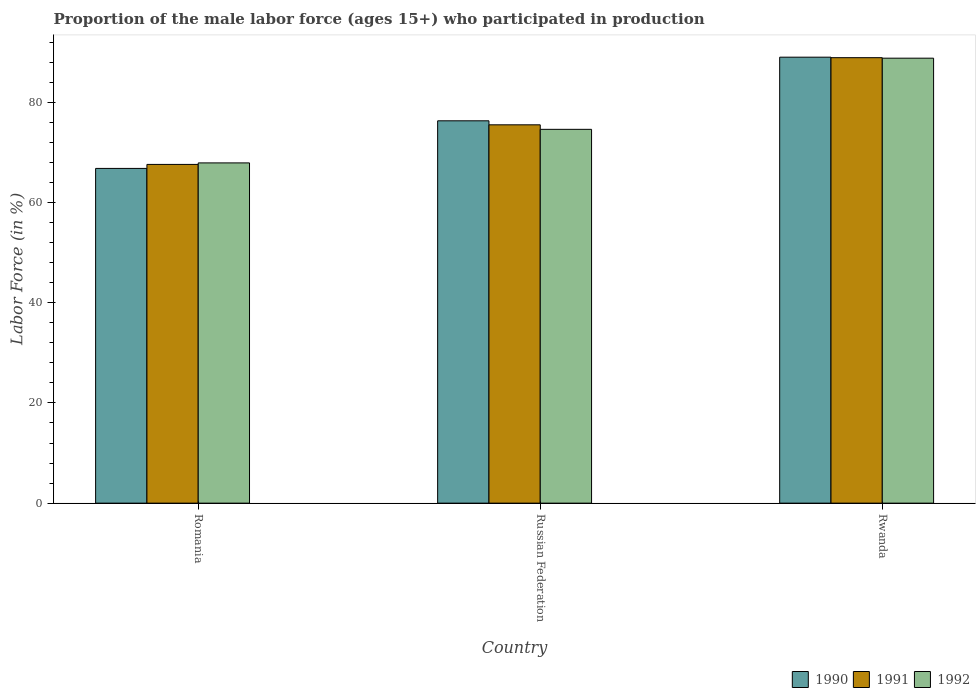Are the number of bars per tick equal to the number of legend labels?
Your response must be concise. Yes. Are the number of bars on each tick of the X-axis equal?
Make the answer very short. Yes. How many bars are there on the 3rd tick from the right?
Your answer should be very brief. 3. What is the label of the 3rd group of bars from the left?
Make the answer very short. Rwanda. What is the proportion of the male labor force who participated in production in 1990 in Romania?
Offer a very short reply. 66.8. Across all countries, what is the maximum proportion of the male labor force who participated in production in 1992?
Offer a very short reply. 88.8. Across all countries, what is the minimum proportion of the male labor force who participated in production in 1991?
Your answer should be compact. 67.6. In which country was the proportion of the male labor force who participated in production in 1990 maximum?
Your response must be concise. Rwanda. In which country was the proportion of the male labor force who participated in production in 1992 minimum?
Your response must be concise. Romania. What is the total proportion of the male labor force who participated in production in 1991 in the graph?
Give a very brief answer. 232. What is the difference between the proportion of the male labor force who participated in production in 1991 in Russian Federation and that in Rwanda?
Your answer should be compact. -13.4. What is the difference between the proportion of the male labor force who participated in production in 1992 in Romania and the proportion of the male labor force who participated in production in 1990 in Rwanda?
Your answer should be very brief. -21.1. What is the average proportion of the male labor force who participated in production in 1990 per country?
Your answer should be compact. 77.37. What is the difference between the proportion of the male labor force who participated in production of/in 1992 and proportion of the male labor force who participated in production of/in 1991 in Rwanda?
Provide a short and direct response. -0.1. What is the ratio of the proportion of the male labor force who participated in production in 1990 in Romania to that in Rwanda?
Give a very brief answer. 0.75. What is the difference between the highest and the second highest proportion of the male labor force who participated in production in 1992?
Keep it short and to the point. 14.2. What is the difference between the highest and the lowest proportion of the male labor force who participated in production in 1992?
Provide a succinct answer. 20.9. Is the sum of the proportion of the male labor force who participated in production in 1990 in Romania and Russian Federation greater than the maximum proportion of the male labor force who participated in production in 1992 across all countries?
Your response must be concise. Yes. What does the 1st bar from the left in Russian Federation represents?
Your response must be concise. 1990. What does the 3rd bar from the right in Romania represents?
Provide a short and direct response. 1990. What is the difference between two consecutive major ticks on the Y-axis?
Ensure brevity in your answer.  20. Are the values on the major ticks of Y-axis written in scientific E-notation?
Give a very brief answer. No. Where does the legend appear in the graph?
Your answer should be very brief. Bottom right. How many legend labels are there?
Ensure brevity in your answer.  3. How are the legend labels stacked?
Your response must be concise. Horizontal. What is the title of the graph?
Keep it short and to the point. Proportion of the male labor force (ages 15+) who participated in production. What is the label or title of the X-axis?
Make the answer very short. Country. What is the Labor Force (in %) of 1990 in Romania?
Give a very brief answer. 66.8. What is the Labor Force (in %) of 1991 in Romania?
Offer a very short reply. 67.6. What is the Labor Force (in %) in 1992 in Romania?
Ensure brevity in your answer.  67.9. What is the Labor Force (in %) in 1990 in Russian Federation?
Provide a succinct answer. 76.3. What is the Labor Force (in %) of 1991 in Russian Federation?
Your answer should be very brief. 75.5. What is the Labor Force (in %) of 1992 in Russian Federation?
Provide a succinct answer. 74.6. What is the Labor Force (in %) in 1990 in Rwanda?
Your answer should be compact. 89. What is the Labor Force (in %) in 1991 in Rwanda?
Give a very brief answer. 88.9. What is the Labor Force (in %) of 1992 in Rwanda?
Provide a succinct answer. 88.8. Across all countries, what is the maximum Labor Force (in %) of 1990?
Provide a succinct answer. 89. Across all countries, what is the maximum Labor Force (in %) of 1991?
Your answer should be compact. 88.9. Across all countries, what is the maximum Labor Force (in %) in 1992?
Your answer should be compact. 88.8. Across all countries, what is the minimum Labor Force (in %) in 1990?
Give a very brief answer. 66.8. Across all countries, what is the minimum Labor Force (in %) in 1991?
Your answer should be very brief. 67.6. Across all countries, what is the minimum Labor Force (in %) in 1992?
Make the answer very short. 67.9. What is the total Labor Force (in %) in 1990 in the graph?
Give a very brief answer. 232.1. What is the total Labor Force (in %) of 1991 in the graph?
Provide a succinct answer. 232. What is the total Labor Force (in %) in 1992 in the graph?
Provide a short and direct response. 231.3. What is the difference between the Labor Force (in %) of 1990 in Romania and that in Russian Federation?
Offer a terse response. -9.5. What is the difference between the Labor Force (in %) of 1992 in Romania and that in Russian Federation?
Offer a very short reply. -6.7. What is the difference between the Labor Force (in %) in 1990 in Romania and that in Rwanda?
Your response must be concise. -22.2. What is the difference between the Labor Force (in %) in 1991 in Romania and that in Rwanda?
Offer a terse response. -21.3. What is the difference between the Labor Force (in %) of 1992 in Romania and that in Rwanda?
Give a very brief answer. -20.9. What is the difference between the Labor Force (in %) of 1991 in Russian Federation and that in Rwanda?
Your answer should be very brief. -13.4. What is the difference between the Labor Force (in %) in 1990 in Romania and the Labor Force (in %) in 1991 in Russian Federation?
Your answer should be compact. -8.7. What is the difference between the Labor Force (in %) of 1990 in Romania and the Labor Force (in %) of 1992 in Russian Federation?
Offer a very short reply. -7.8. What is the difference between the Labor Force (in %) in 1991 in Romania and the Labor Force (in %) in 1992 in Russian Federation?
Give a very brief answer. -7. What is the difference between the Labor Force (in %) in 1990 in Romania and the Labor Force (in %) in 1991 in Rwanda?
Provide a short and direct response. -22.1. What is the difference between the Labor Force (in %) of 1991 in Romania and the Labor Force (in %) of 1992 in Rwanda?
Provide a succinct answer. -21.2. What is the difference between the Labor Force (in %) of 1990 in Russian Federation and the Labor Force (in %) of 1991 in Rwanda?
Offer a very short reply. -12.6. What is the difference between the Labor Force (in %) of 1990 in Russian Federation and the Labor Force (in %) of 1992 in Rwanda?
Give a very brief answer. -12.5. What is the average Labor Force (in %) of 1990 per country?
Your answer should be very brief. 77.37. What is the average Labor Force (in %) in 1991 per country?
Offer a very short reply. 77.33. What is the average Labor Force (in %) in 1992 per country?
Provide a succinct answer. 77.1. What is the difference between the Labor Force (in %) of 1990 and Labor Force (in %) of 1991 in Russian Federation?
Your answer should be very brief. 0.8. What is the difference between the Labor Force (in %) of 1990 and Labor Force (in %) of 1991 in Rwanda?
Provide a short and direct response. 0.1. What is the ratio of the Labor Force (in %) in 1990 in Romania to that in Russian Federation?
Make the answer very short. 0.88. What is the ratio of the Labor Force (in %) in 1991 in Romania to that in Russian Federation?
Provide a succinct answer. 0.9. What is the ratio of the Labor Force (in %) of 1992 in Romania to that in Russian Federation?
Offer a very short reply. 0.91. What is the ratio of the Labor Force (in %) in 1990 in Romania to that in Rwanda?
Offer a very short reply. 0.75. What is the ratio of the Labor Force (in %) in 1991 in Romania to that in Rwanda?
Keep it short and to the point. 0.76. What is the ratio of the Labor Force (in %) of 1992 in Romania to that in Rwanda?
Give a very brief answer. 0.76. What is the ratio of the Labor Force (in %) in 1990 in Russian Federation to that in Rwanda?
Offer a very short reply. 0.86. What is the ratio of the Labor Force (in %) in 1991 in Russian Federation to that in Rwanda?
Provide a succinct answer. 0.85. What is the ratio of the Labor Force (in %) in 1992 in Russian Federation to that in Rwanda?
Provide a succinct answer. 0.84. What is the difference between the highest and the second highest Labor Force (in %) in 1990?
Offer a terse response. 12.7. What is the difference between the highest and the lowest Labor Force (in %) in 1990?
Make the answer very short. 22.2. What is the difference between the highest and the lowest Labor Force (in %) of 1991?
Provide a short and direct response. 21.3. What is the difference between the highest and the lowest Labor Force (in %) of 1992?
Offer a very short reply. 20.9. 